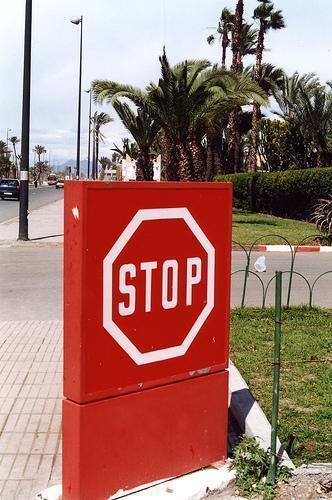How many stop signs are there?
Give a very brief answer. 1. 